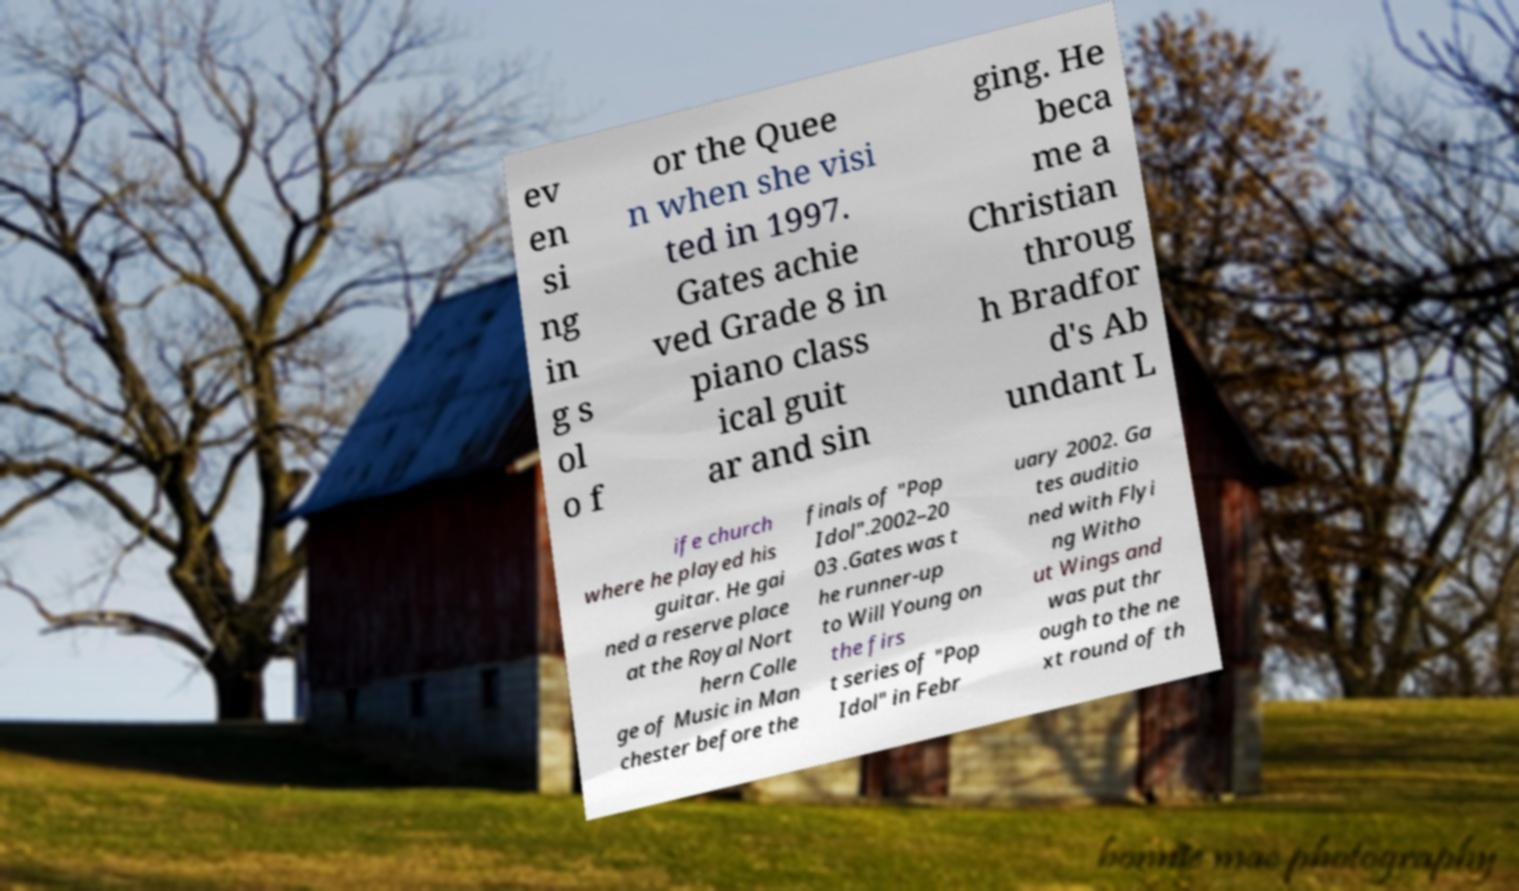Can you accurately transcribe the text from the provided image for me? ev en si ng in g s ol o f or the Quee n when she visi ted in 1997. Gates achie ved Grade 8 in piano class ical guit ar and sin ging. He beca me a Christian throug h Bradfor d's Ab undant L ife church where he played his guitar. He gai ned a reserve place at the Royal Nort hern Colle ge of Music in Man chester before the finals of "Pop Idol".2002–20 03 .Gates was t he runner-up to Will Young on the firs t series of "Pop Idol" in Febr uary 2002. Ga tes auditio ned with Flyi ng Witho ut Wings and was put thr ough to the ne xt round of th 